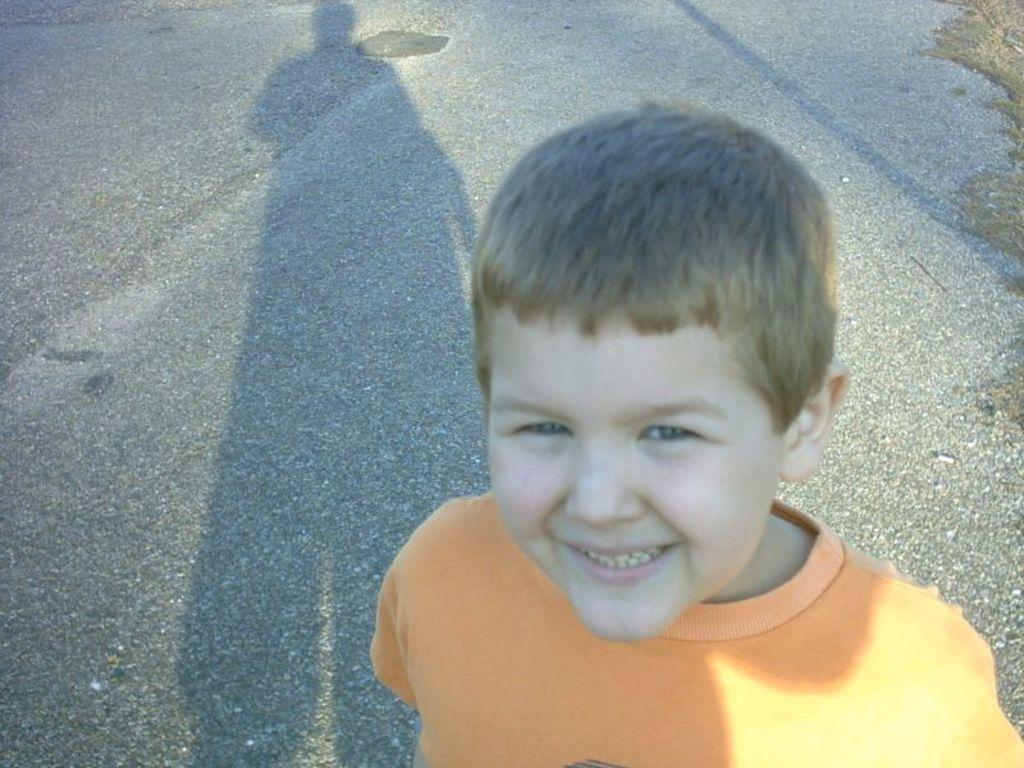Who or what is present in the image? There is a person in the image. What can be seen in the background of the image? There is a road in the background of the image. What is visible on the road in the image? The person's shadow is visible on the road. What type of vegetation is on the right side of the image? There is grass on the right side of the image. What type of alley is visible in the image? There is no alley present in the image; it features a person, a road, and grass. Where is the spot where the person is standing in the image? The person's exact location cannot be determined from the image, but their shadow is visible on the road. 